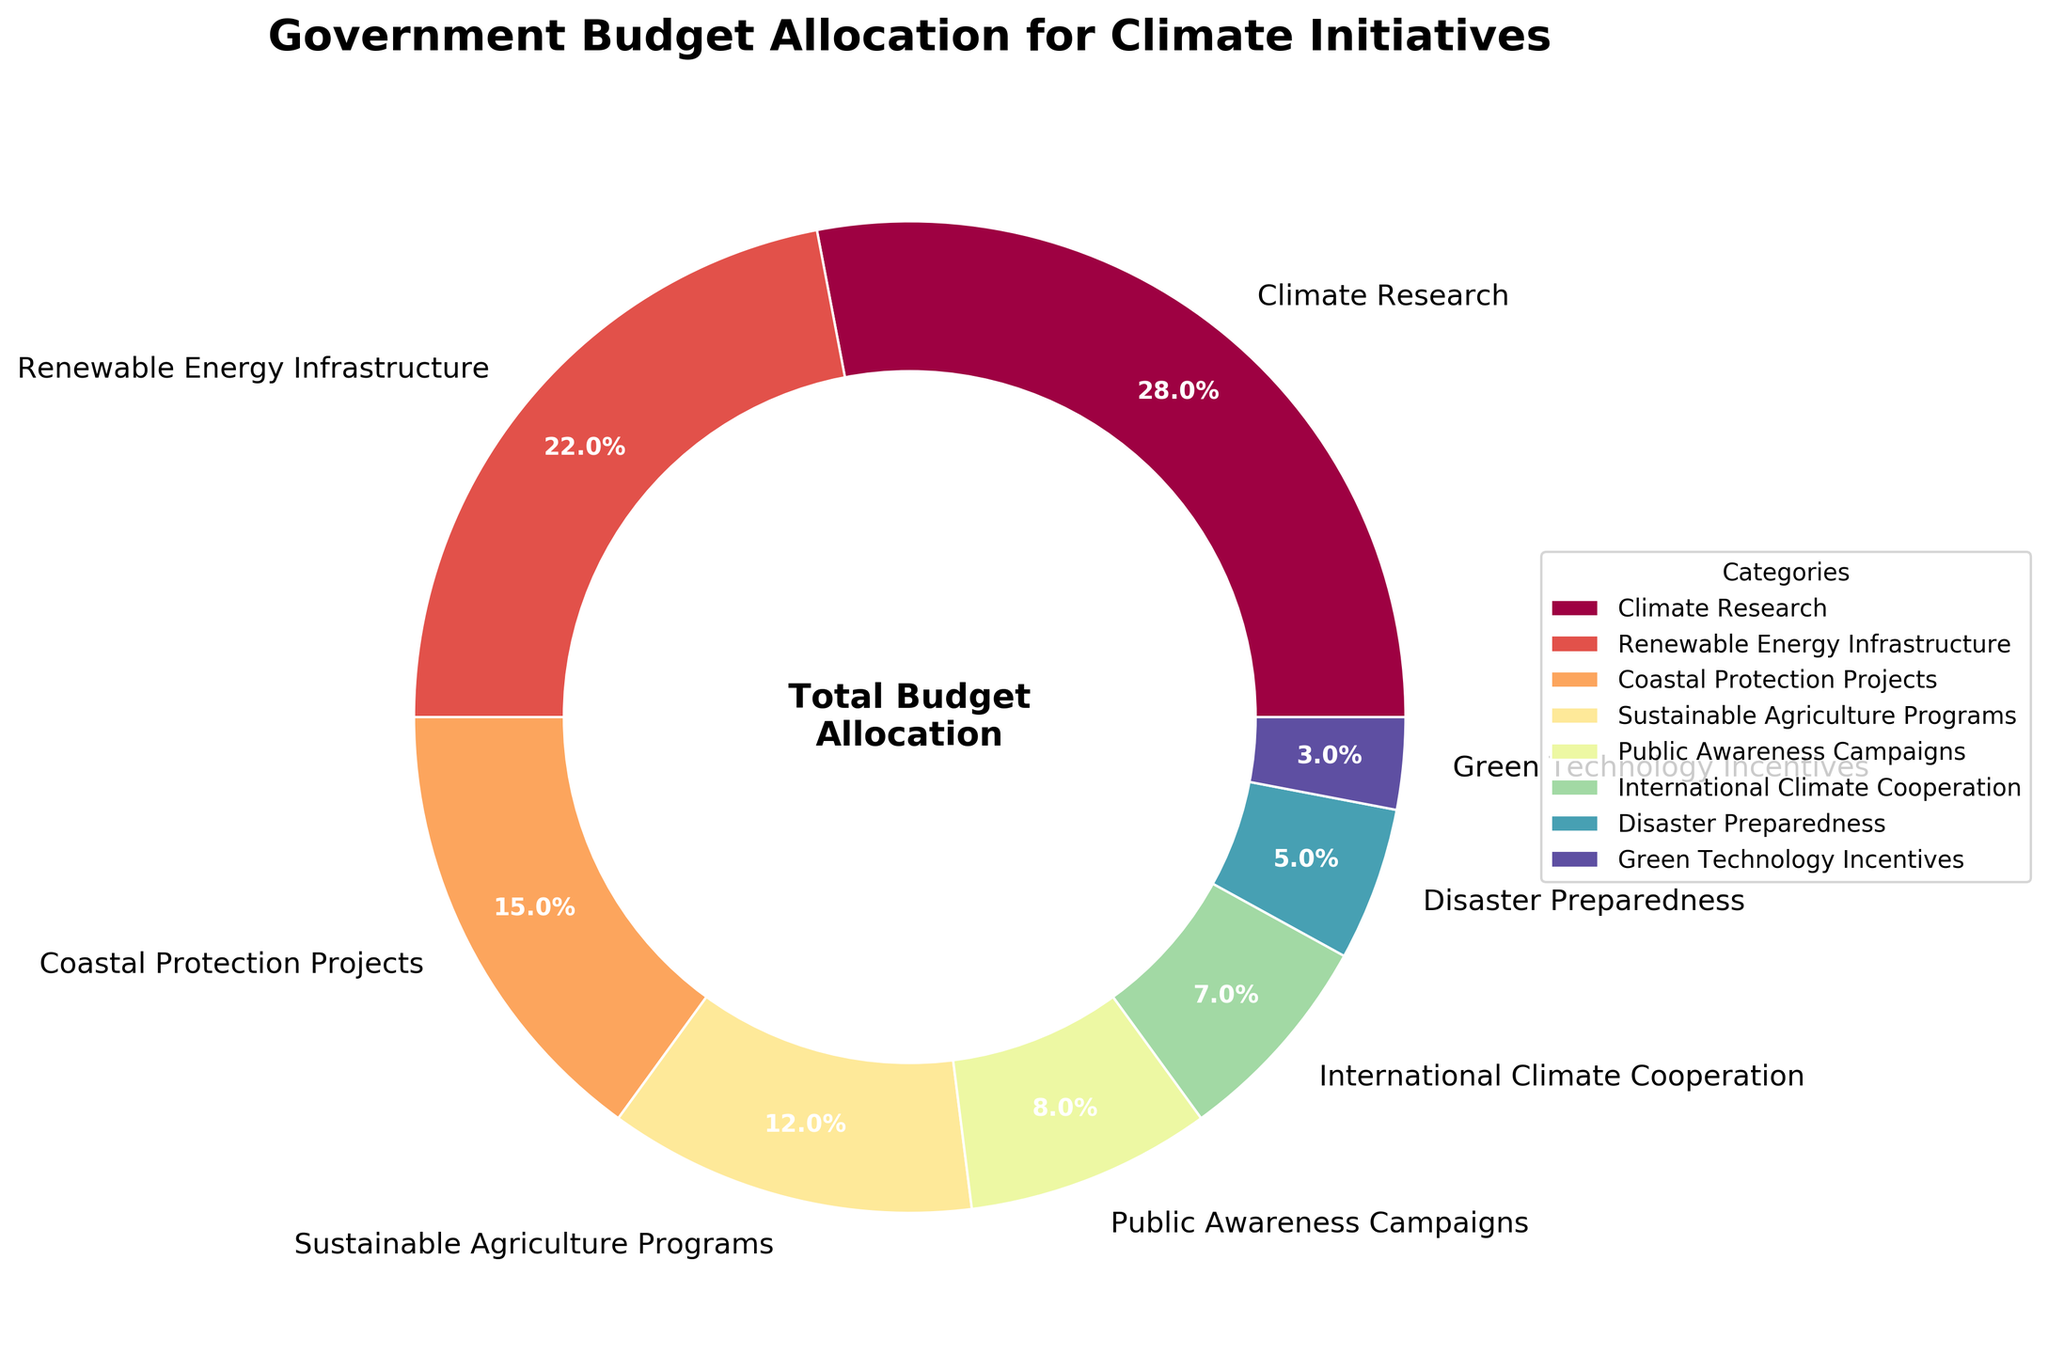what is the primary category where the government has allocated the highest budget percentage? The category with the highest percentage can be identified as the largest wedge in the pie. The "Climate Research" wedge is the largest in the chart with 28%.
Answer: Climate Research Which budget allocation categories combined make up more than 50% of the budget? To determine this, we add the percentages of the largest categories until the sum exceeds 50%. "Climate Research" (28%) + "Renewable Energy Infrastructure" (22%) sums to 50%, and just adding these two categories, we reach exactly 50%. As 50% is not clearly more than 50%, we consider additional categories. Adding "Coastal Protection Projects" (15%) gives us 65%, which is more than 50%.
Answer: Climate Research, Renewable Energy Infrastructure, Coastal Protection Projects How much more is allocated for Climate Research compared to Disaster Preparedness? We need to subtract the percentage of the "Disaster Preparedness" category from the "Climate Research" category. 28% - 5% = 23%.
Answer: 23% What percentage of the budget is devoted to Public Awareness Campaigns and Green Technology Incentives combined? Adding the percentages of "Public Awareness Campaigns" (8%) and "Green Technology Incentives" (3%) gives 8% + 3% = 11%.
Answer: 11% Is the budget for Sustainable Agriculture Programs greater than that for International Climate Cooperation? By comparing the percentages of the two categories, "Sustainable Agriculture Programs" is 12% and "International Climate Cooperation" is 7%. Since 12% > 7%, the answer is yes.
Answer: Yes Which color represents the category Sustainable Agriculture Programs in the pie chart? By examining the legend associated with the pie chart, we find the color corresponding to "Sustainable Agriculture Programs". According to the colormap, this wedge is yellow.
Answer: Yellow What is the total percentage allocated to categories receiving less than 10% of the budget each? Adding percentages of "Public Awareness Campaigns" (8%), "International Climate Cooperation" (7%), "Disaster Preparedness" (5%), "Green Technology Incentives" (3%) gives the sum 8% + 7% + 5% + 3% = 23%.
Answer: 23% How does the budget for Renewable Energy Infrastructure compare to that for Coastal Protection Projects and Disaster Preparedness combined? We add the percentages for "Coastal Protection Projects" (15%) and "Disaster Preparedness" (5%) to get 15% + 5% = 20%. Comparing this to the budget for "Renewable Energy Infrastructure" (22%), we see that 22% > 20%.
Answer: Higher 